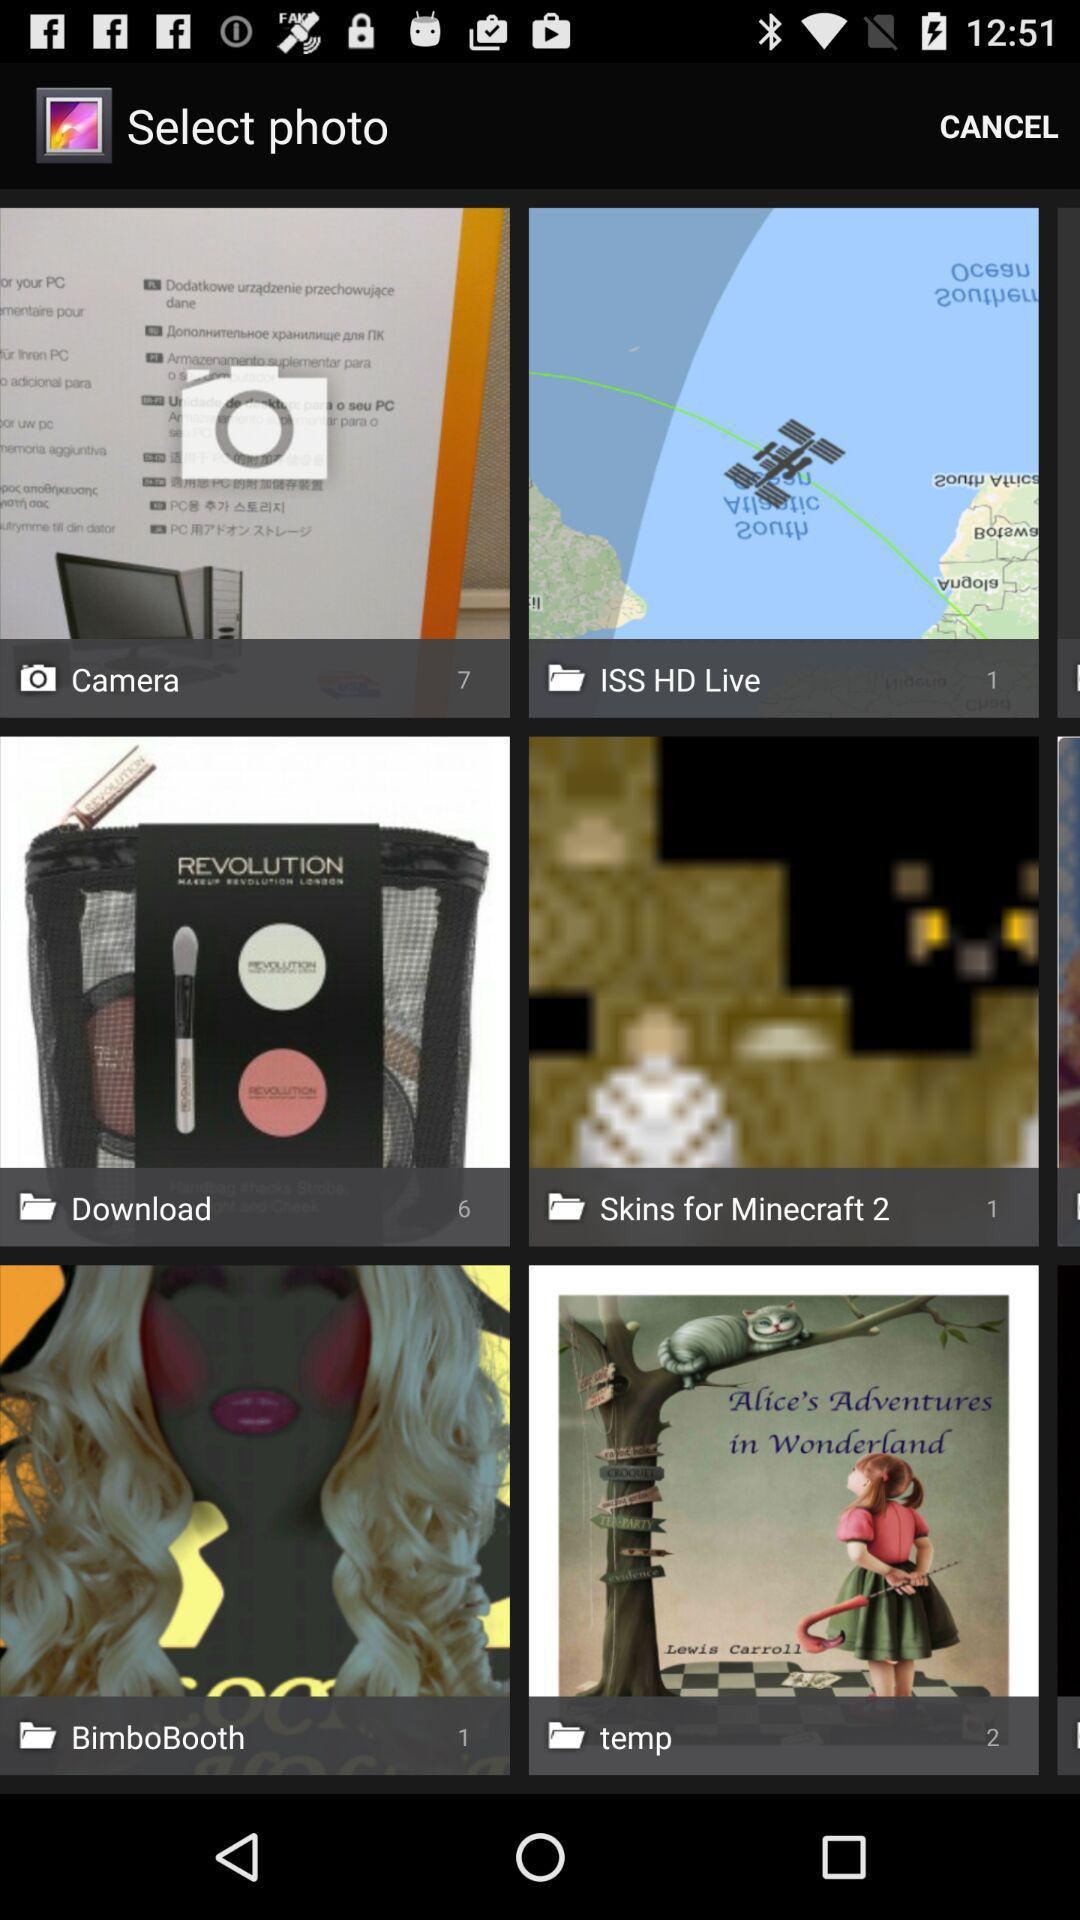What is the number of images in the "Download" album? The number of images in the "Download" album is 6. 